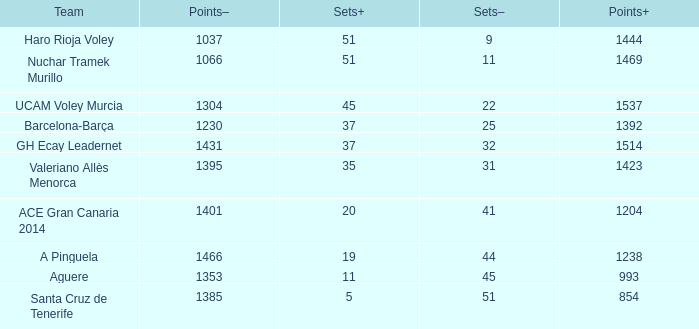What is the total number of Points- when the Sets- is larger than 51? 0.0. 